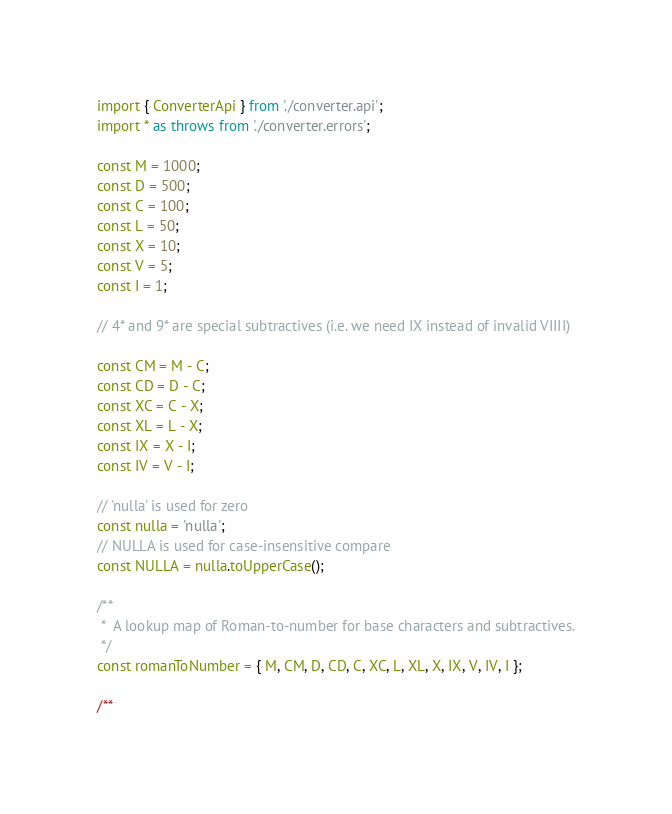<code> <loc_0><loc_0><loc_500><loc_500><_TypeScript_>import { ConverterApi } from './converter.api';
import * as throws from './converter.errors';

const M = 1000;
const D = 500;
const C = 100;
const L = 50;
const X = 10;
const V = 5;
const I = 1;

// 4* and 9* are special subtractives (i.e. we need IX instead of invalid VIIII)

const CM = M - C;
const CD = D - C;
const XC = C - X;
const XL = L - X;
const IX = X - I;
const IV = V - I;

// 'nulla' is used for zero
const nulla = 'nulla';
// NULLA is used for case-insensitive compare
const NULLA = nulla.toUpperCase();

/**
 *  A lookup map of Roman-to-number for base characters and subtractives.
 */
const romanToNumber = { M, CM, D, CD, C, XC, L, XL, X, IX, V, IV, I };

/**</code> 